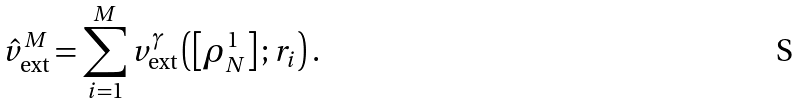Convert formula to latex. <formula><loc_0><loc_0><loc_500><loc_500>\hat { v } _ { \text {ext} } ^ { M } = \sum _ { i = 1 } ^ { M } v _ { \text {ext} } ^ { \gamma } \left ( \left [ \rho _ { N } ^ { 1 } \right ] ; r _ { i } \right ) .</formula> 